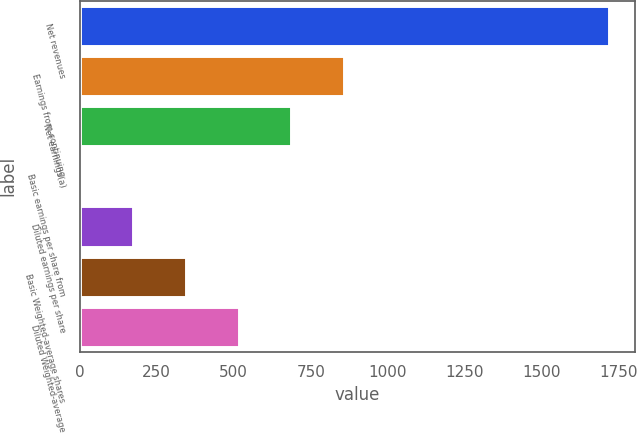Convert chart to OTSL. <chart><loc_0><loc_0><loc_500><loc_500><bar_chart><fcel>Net revenues<fcel>Earnings from continuing<fcel>Net earnings(a)<fcel>Basic earnings per share from<fcel>Diluted earnings per share<fcel>Basic Weighted-average shares<fcel>Diluted Weighted-average<nl><fcel>1717.1<fcel>859.15<fcel>687.56<fcel>1.2<fcel>172.79<fcel>344.38<fcel>515.97<nl></chart> 